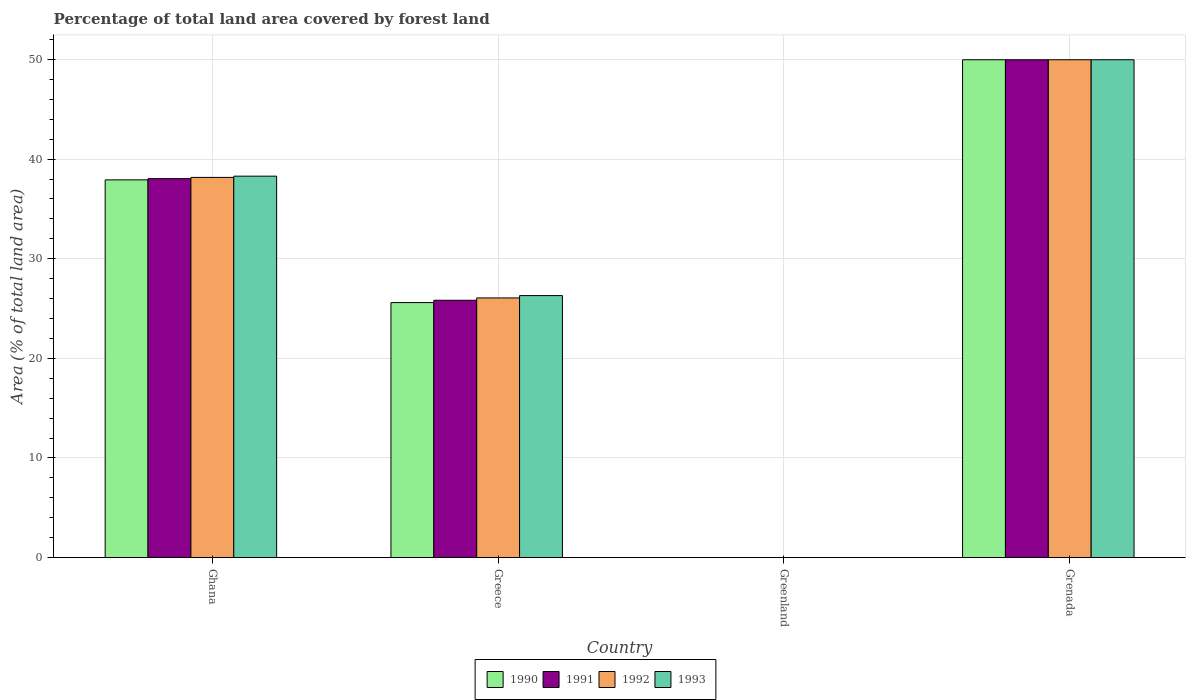How many groups of bars are there?
Offer a terse response. 4. How many bars are there on the 4th tick from the left?
Give a very brief answer. 4. How many bars are there on the 2nd tick from the right?
Your answer should be compact. 4. What is the label of the 4th group of bars from the left?
Keep it short and to the point. Grenada. In how many cases, is the number of bars for a given country not equal to the number of legend labels?
Provide a succinct answer. 0. What is the percentage of forest land in 1991 in Greece?
Your answer should be very brief. 25.83. Across all countries, what is the maximum percentage of forest land in 1990?
Provide a short and direct response. 49.97. Across all countries, what is the minimum percentage of forest land in 1991?
Offer a very short reply. 0. In which country was the percentage of forest land in 1990 maximum?
Your response must be concise. Grenada. In which country was the percentage of forest land in 1992 minimum?
Your answer should be compact. Greenland. What is the total percentage of forest land in 1990 in the graph?
Your response must be concise. 113.48. What is the difference between the percentage of forest land in 1992 in Greece and that in Greenland?
Ensure brevity in your answer.  26.06. What is the difference between the percentage of forest land in 1990 in Greece and the percentage of forest land in 1992 in Grenada?
Ensure brevity in your answer.  -24.38. What is the average percentage of forest land in 1991 per country?
Offer a terse response. 28.46. What is the difference between the percentage of forest land of/in 1993 and percentage of forest land of/in 1992 in Grenada?
Your response must be concise. 0. In how many countries, is the percentage of forest land in 1991 greater than 6 %?
Offer a very short reply. 3. What is the ratio of the percentage of forest land in 1993 in Greece to that in Grenada?
Offer a very short reply. 0.53. Is the percentage of forest land in 1993 in Ghana less than that in Greenland?
Offer a terse response. No. Is the difference between the percentage of forest land in 1993 in Ghana and Greece greater than the difference between the percentage of forest land in 1992 in Ghana and Greece?
Offer a terse response. No. What is the difference between the highest and the second highest percentage of forest land in 1990?
Offer a terse response. 12.06. What is the difference between the highest and the lowest percentage of forest land in 1990?
Provide a succinct answer. 49.97. In how many countries, is the percentage of forest land in 1990 greater than the average percentage of forest land in 1990 taken over all countries?
Make the answer very short. 2. Is the sum of the percentage of forest land in 1991 in Greenland and Grenada greater than the maximum percentage of forest land in 1992 across all countries?
Provide a short and direct response. Yes. Is it the case that in every country, the sum of the percentage of forest land in 1992 and percentage of forest land in 1993 is greater than the sum of percentage of forest land in 1990 and percentage of forest land in 1991?
Ensure brevity in your answer.  No. What does the 1st bar from the right in Greece represents?
Offer a very short reply. 1993. Are all the bars in the graph horizontal?
Your response must be concise. No. What is the difference between two consecutive major ticks on the Y-axis?
Offer a very short reply. 10. Are the values on the major ticks of Y-axis written in scientific E-notation?
Your answer should be compact. No. How are the legend labels stacked?
Provide a succinct answer. Horizontal. What is the title of the graph?
Your answer should be compact. Percentage of total land area covered by forest land. What is the label or title of the X-axis?
Keep it short and to the point. Country. What is the label or title of the Y-axis?
Keep it short and to the point. Area (% of total land area). What is the Area (% of total land area) in 1990 in Ghana?
Ensure brevity in your answer.  37.91. What is the Area (% of total land area) of 1991 in Ghana?
Your answer should be very brief. 38.04. What is the Area (% of total land area) of 1992 in Ghana?
Keep it short and to the point. 38.16. What is the Area (% of total land area) in 1993 in Ghana?
Ensure brevity in your answer.  38.29. What is the Area (% of total land area) of 1990 in Greece?
Ensure brevity in your answer.  25.59. What is the Area (% of total land area) of 1991 in Greece?
Offer a terse response. 25.83. What is the Area (% of total land area) of 1992 in Greece?
Keep it short and to the point. 26.06. What is the Area (% of total land area) in 1993 in Greece?
Provide a short and direct response. 26.3. What is the Area (% of total land area) of 1990 in Greenland?
Make the answer very short. 0. What is the Area (% of total land area) in 1991 in Greenland?
Keep it short and to the point. 0. What is the Area (% of total land area) of 1992 in Greenland?
Your answer should be compact. 0. What is the Area (% of total land area) in 1993 in Greenland?
Give a very brief answer. 0. What is the Area (% of total land area) in 1990 in Grenada?
Your answer should be very brief. 49.97. What is the Area (% of total land area) of 1991 in Grenada?
Keep it short and to the point. 49.97. What is the Area (% of total land area) in 1992 in Grenada?
Make the answer very short. 49.97. What is the Area (% of total land area) of 1993 in Grenada?
Offer a terse response. 49.97. Across all countries, what is the maximum Area (% of total land area) in 1990?
Offer a very short reply. 49.97. Across all countries, what is the maximum Area (% of total land area) in 1991?
Provide a succinct answer. 49.97. Across all countries, what is the maximum Area (% of total land area) in 1992?
Ensure brevity in your answer.  49.97. Across all countries, what is the maximum Area (% of total land area) in 1993?
Provide a succinct answer. 49.97. Across all countries, what is the minimum Area (% of total land area) in 1990?
Your answer should be very brief. 0. Across all countries, what is the minimum Area (% of total land area) in 1991?
Your answer should be compact. 0. Across all countries, what is the minimum Area (% of total land area) in 1992?
Keep it short and to the point. 0. Across all countries, what is the minimum Area (% of total land area) in 1993?
Keep it short and to the point. 0. What is the total Area (% of total land area) of 1990 in the graph?
Your answer should be very brief. 113.48. What is the total Area (% of total land area) in 1991 in the graph?
Ensure brevity in your answer.  113.84. What is the total Area (% of total land area) in 1992 in the graph?
Provide a succinct answer. 114.2. What is the total Area (% of total land area) of 1993 in the graph?
Ensure brevity in your answer.  114.55. What is the difference between the Area (% of total land area) of 1990 in Ghana and that in Greece?
Give a very brief answer. 12.32. What is the difference between the Area (% of total land area) of 1991 in Ghana and that in Greece?
Give a very brief answer. 12.21. What is the difference between the Area (% of total land area) in 1992 in Ghana and that in Greece?
Provide a short and direct response. 12.1. What is the difference between the Area (% of total land area) of 1993 in Ghana and that in Greece?
Provide a succinct answer. 11.99. What is the difference between the Area (% of total land area) of 1990 in Ghana and that in Greenland?
Offer a very short reply. 37.91. What is the difference between the Area (% of total land area) in 1991 in Ghana and that in Greenland?
Ensure brevity in your answer.  38.04. What is the difference between the Area (% of total land area) of 1992 in Ghana and that in Greenland?
Provide a succinct answer. 38.16. What is the difference between the Area (% of total land area) of 1993 in Ghana and that in Greenland?
Your response must be concise. 38.29. What is the difference between the Area (% of total land area) of 1990 in Ghana and that in Grenada?
Make the answer very short. -12.06. What is the difference between the Area (% of total land area) of 1991 in Ghana and that in Grenada?
Offer a very short reply. -11.93. What is the difference between the Area (% of total land area) in 1992 in Ghana and that in Grenada?
Give a very brief answer. -11.81. What is the difference between the Area (% of total land area) in 1993 in Ghana and that in Grenada?
Offer a very short reply. -11.68. What is the difference between the Area (% of total land area) of 1990 in Greece and that in Greenland?
Offer a very short reply. 25.59. What is the difference between the Area (% of total land area) in 1991 in Greece and that in Greenland?
Provide a short and direct response. 25.83. What is the difference between the Area (% of total land area) in 1992 in Greece and that in Greenland?
Offer a very short reply. 26.06. What is the difference between the Area (% of total land area) in 1993 in Greece and that in Greenland?
Provide a succinct answer. 26.3. What is the difference between the Area (% of total land area) in 1990 in Greece and that in Grenada?
Ensure brevity in your answer.  -24.38. What is the difference between the Area (% of total land area) of 1991 in Greece and that in Grenada?
Keep it short and to the point. -24.14. What is the difference between the Area (% of total land area) in 1992 in Greece and that in Grenada?
Offer a very short reply. -23.91. What is the difference between the Area (% of total land area) in 1993 in Greece and that in Grenada?
Your answer should be very brief. -23.67. What is the difference between the Area (% of total land area) in 1990 in Greenland and that in Grenada?
Provide a succinct answer. -49.97. What is the difference between the Area (% of total land area) in 1991 in Greenland and that in Grenada?
Ensure brevity in your answer.  -49.97. What is the difference between the Area (% of total land area) of 1992 in Greenland and that in Grenada?
Keep it short and to the point. -49.97. What is the difference between the Area (% of total land area) of 1993 in Greenland and that in Grenada?
Provide a short and direct response. -49.97. What is the difference between the Area (% of total land area) of 1990 in Ghana and the Area (% of total land area) of 1991 in Greece?
Make the answer very short. 12.09. What is the difference between the Area (% of total land area) in 1990 in Ghana and the Area (% of total land area) in 1992 in Greece?
Keep it short and to the point. 11.85. What is the difference between the Area (% of total land area) in 1990 in Ghana and the Area (% of total land area) in 1993 in Greece?
Make the answer very short. 11.62. What is the difference between the Area (% of total land area) in 1991 in Ghana and the Area (% of total land area) in 1992 in Greece?
Your answer should be very brief. 11.98. What is the difference between the Area (% of total land area) in 1991 in Ghana and the Area (% of total land area) in 1993 in Greece?
Provide a succinct answer. 11.74. What is the difference between the Area (% of total land area) in 1992 in Ghana and the Area (% of total land area) in 1993 in Greece?
Your response must be concise. 11.87. What is the difference between the Area (% of total land area) of 1990 in Ghana and the Area (% of total land area) of 1991 in Greenland?
Keep it short and to the point. 37.91. What is the difference between the Area (% of total land area) in 1990 in Ghana and the Area (% of total land area) in 1992 in Greenland?
Provide a succinct answer. 37.91. What is the difference between the Area (% of total land area) in 1990 in Ghana and the Area (% of total land area) in 1993 in Greenland?
Your answer should be compact. 37.91. What is the difference between the Area (% of total land area) in 1991 in Ghana and the Area (% of total land area) in 1992 in Greenland?
Your answer should be very brief. 38.04. What is the difference between the Area (% of total land area) in 1991 in Ghana and the Area (% of total land area) in 1993 in Greenland?
Your answer should be very brief. 38.04. What is the difference between the Area (% of total land area) in 1992 in Ghana and the Area (% of total land area) in 1993 in Greenland?
Offer a terse response. 38.16. What is the difference between the Area (% of total land area) in 1990 in Ghana and the Area (% of total land area) in 1991 in Grenada?
Ensure brevity in your answer.  -12.06. What is the difference between the Area (% of total land area) of 1990 in Ghana and the Area (% of total land area) of 1992 in Grenada?
Your response must be concise. -12.06. What is the difference between the Area (% of total land area) in 1990 in Ghana and the Area (% of total land area) in 1993 in Grenada?
Ensure brevity in your answer.  -12.06. What is the difference between the Area (% of total land area) of 1991 in Ghana and the Area (% of total land area) of 1992 in Grenada?
Offer a very short reply. -11.93. What is the difference between the Area (% of total land area) in 1991 in Ghana and the Area (% of total land area) in 1993 in Grenada?
Provide a succinct answer. -11.93. What is the difference between the Area (% of total land area) of 1992 in Ghana and the Area (% of total land area) of 1993 in Grenada?
Ensure brevity in your answer.  -11.81. What is the difference between the Area (% of total land area) of 1990 in Greece and the Area (% of total land area) of 1991 in Greenland?
Give a very brief answer. 25.59. What is the difference between the Area (% of total land area) in 1990 in Greece and the Area (% of total land area) in 1992 in Greenland?
Offer a very short reply. 25.59. What is the difference between the Area (% of total land area) of 1990 in Greece and the Area (% of total land area) of 1993 in Greenland?
Make the answer very short. 25.59. What is the difference between the Area (% of total land area) of 1991 in Greece and the Area (% of total land area) of 1992 in Greenland?
Your answer should be very brief. 25.83. What is the difference between the Area (% of total land area) of 1991 in Greece and the Area (% of total land area) of 1993 in Greenland?
Your answer should be very brief. 25.83. What is the difference between the Area (% of total land area) of 1992 in Greece and the Area (% of total land area) of 1993 in Greenland?
Offer a terse response. 26.06. What is the difference between the Area (% of total land area) of 1990 in Greece and the Area (% of total land area) of 1991 in Grenada?
Give a very brief answer. -24.38. What is the difference between the Area (% of total land area) of 1990 in Greece and the Area (% of total land area) of 1992 in Grenada?
Make the answer very short. -24.38. What is the difference between the Area (% of total land area) in 1990 in Greece and the Area (% of total land area) in 1993 in Grenada?
Provide a succinct answer. -24.38. What is the difference between the Area (% of total land area) in 1991 in Greece and the Area (% of total land area) in 1992 in Grenada?
Provide a succinct answer. -24.14. What is the difference between the Area (% of total land area) of 1991 in Greece and the Area (% of total land area) of 1993 in Grenada?
Give a very brief answer. -24.14. What is the difference between the Area (% of total land area) in 1992 in Greece and the Area (% of total land area) in 1993 in Grenada?
Make the answer very short. -23.91. What is the difference between the Area (% of total land area) of 1990 in Greenland and the Area (% of total land area) of 1991 in Grenada?
Offer a terse response. -49.97. What is the difference between the Area (% of total land area) in 1990 in Greenland and the Area (% of total land area) in 1992 in Grenada?
Offer a very short reply. -49.97. What is the difference between the Area (% of total land area) in 1990 in Greenland and the Area (% of total land area) in 1993 in Grenada?
Your answer should be very brief. -49.97. What is the difference between the Area (% of total land area) in 1991 in Greenland and the Area (% of total land area) in 1992 in Grenada?
Give a very brief answer. -49.97. What is the difference between the Area (% of total land area) in 1991 in Greenland and the Area (% of total land area) in 1993 in Grenada?
Your response must be concise. -49.97. What is the difference between the Area (% of total land area) in 1992 in Greenland and the Area (% of total land area) in 1993 in Grenada?
Offer a very short reply. -49.97. What is the average Area (% of total land area) in 1990 per country?
Offer a terse response. 28.37. What is the average Area (% of total land area) of 1991 per country?
Your response must be concise. 28.46. What is the average Area (% of total land area) of 1992 per country?
Keep it short and to the point. 28.55. What is the average Area (% of total land area) of 1993 per country?
Give a very brief answer. 28.64. What is the difference between the Area (% of total land area) of 1990 and Area (% of total land area) of 1991 in Ghana?
Offer a very short reply. -0.12. What is the difference between the Area (% of total land area) in 1990 and Area (% of total land area) in 1992 in Ghana?
Provide a short and direct response. -0.25. What is the difference between the Area (% of total land area) in 1990 and Area (% of total land area) in 1993 in Ghana?
Provide a short and direct response. -0.37. What is the difference between the Area (% of total land area) of 1991 and Area (% of total land area) of 1992 in Ghana?
Provide a succinct answer. -0.12. What is the difference between the Area (% of total land area) in 1991 and Area (% of total land area) in 1993 in Ghana?
Offer a terse response. -0.25. What is the difference between the Area (% of total land area) in 1992 and Area (% of total land area) in 1993 in Ghana?
Give a very brief answer. -0.12. What is the difference between the Area (% of total land area) of 1990 and Area (% of total land area) of 1991 in Greece?
Offer a terse response. -0.23. What is the difference between the Area (% of total land area) in 1990 and Area (% of total land area) in 1992 in Greece?
Offer a very short reply. -0.47. What is the difference between the Area (% of total land area) of 1990 and Area (% of total land area) of 1993 in Greece?
Your answer should be very brief. -0.7. What is the difference between the Area (% of total land area) of 1991 and Area (% of total land area) of 1992 in Greece?
Your response must be concise. -0.23. What is the difference between the Area (% of total land area) of 1991 and Area (% of total land area) of 1993 in Greece?
Provide a succinct answer. -0.47. What is the difference between the Area (% of total land area) in 1992 and Area (% of total land area) in 1993 in Greece?
Provide a succinct answer. -0.23. What is the difference between the Area (% of total land area) in 1990 and Area (% of total land area) in 1991 in Greenland?
Keep it short and to the point. 0. What is the difference between the Area (% of total land area) of 1990 and Area (% of total land area) of 1992 in Greenland?
Offer a terse response. 0. What is the difference between the Area (% of total land area) in 1990 and Area (% of total land area) in 1993 in Greenland?
Provide a succinct answer. 0. What is the difference between the Area (% of total land area) of 1991 and Area (% of total land area) of 1993 in Greenland?
Make the answer very short. 0. What is the difference between the Area (% of total land area) in 1990 and Area (% of total land area) in 1993 in Grenada?
Keep it short and to the point. 0. What is the difference between the Area (% of total land area) of 1991 and Area (% of total land area) of 1992 in Grenada?
Give a very brief answer. 0. What is the ratio of the Area (% of total land area) in 1990 in Ghana to that in Greece?
Your answer should be compact. 1.48. What is the ratio of the Area (% of total land area) of 1991 in Ghana to that in Greece?
Provide a succinct answer. 1.47. What is the ratio of the Area (% of total land area) of 1992 in Ghana to that in Greece?
Make the answer very short. 1.46. What is the ratio of the Area (% of total land area) of 1993 in Ghana to that in Greece?
Provide a succinct answer. 1.46. What is the ratio of the Area (% of total land area) in 1990 in Ghana to that in Greenland?
Give a very brief answer. 5.89e+04. What is the ratio of the Area (% of total land area) in 1991 in Ghana to that in Greenland?
Your response must be concise. 5.91e+04. What is the ratio of the Area (% of total land area) of 1992 in Ghana to that in Greenland?
Offer a terse response. 5.93e+04. What is the ratio of the Area (% of total land area) of 1993 in Ghana to that in Greenland?
Ensure brevity in your answer.  5.95e+04. What is the ratio of the Area (% of total land area) of 1990 in Ghana to that in Grenada?
Your answer should be very brief. 0.76. What is the ratio of the Area (% of total land area) of 1991 in Ghana to that in Grenada?
Keep it short and to the point. 0.76. What is the ratio of the Area (% of total land area) of 1992 in Ghana to that in Grenada?
Provide a succinct answer. 0.76. What is the ratio of the Area (% of total land area) of 1993 in Ghana to that in Grenada?
Give a very brief answer. 0.77. What is the ratio of the Area (% of total land area) of 1990 in Greece to that in Greenland?
Offer a very short reply. 3.98e+04. What is the ratio of the Area (% of total land area) of 1991 in Greece to that in Greenland?
Make the answer very short. 4.01e+04. What is the ratio of the Area (% of total land area) in 1992 in Greece to that in Greenland?
Give a very brief answer. 4.05e+04. What is the ratio of the Area (% of total land area) in 1993 in Greece to that in Greenland?
Keep it short and to the point. 4.08e+04. What is the ratio of the Area (% of total land area) of 1990 in Greece to that in Grenada?
Your answer should be compact. 0.51. What is the ratio of the Area (% of total land area) of 1991 in Greece to that in Grenada?
Offer a terse response. 0.52. What is the ratio of the Area (% of total land area) of 1992 in Greece to that in Grenada?
Make the answer very short. 0.52. What is the ratio of the Area (% of total land area) of 1993 in Greece to that in Grenada?
Provide a succinct answer. 0.53. What is the ratio of the Area (% of total land area) in 1991 in Greenland to that in Grenada?
Ensure brevity in your answer.  0. What is the difference between the highest and the second highest Area (% of total land area) in 1990?
Provide a short and direct response. 12.06. What is the difference between the highest and the second highest Area (% of total land area) of 1991?
Ensure brevity in your answer.  11.93. What is the difference between the highest and the second highest Area (% of total land area) in 1992?
Offer a terse response. 11.81. What is the difference between the highest and the second highest Area (% of total land area) in 1993?
Make the answer very short. 11.68. What is the difference between the highest and the lowest Area (% of total land area) in 1990?
Your response must be concise. 49.97. What is the difference between the highest and the lowest Area (% of total land area) of 1991?
Offer a terse response. 49.97. What is the difference between the highest and the lowest Area (% of total land area) of 1992?
Offer a terse response. 49.97. What is the difference between the highest and the lowest Area (% of total land area) of 1993?
Provide a short and direct response. 49.97. 